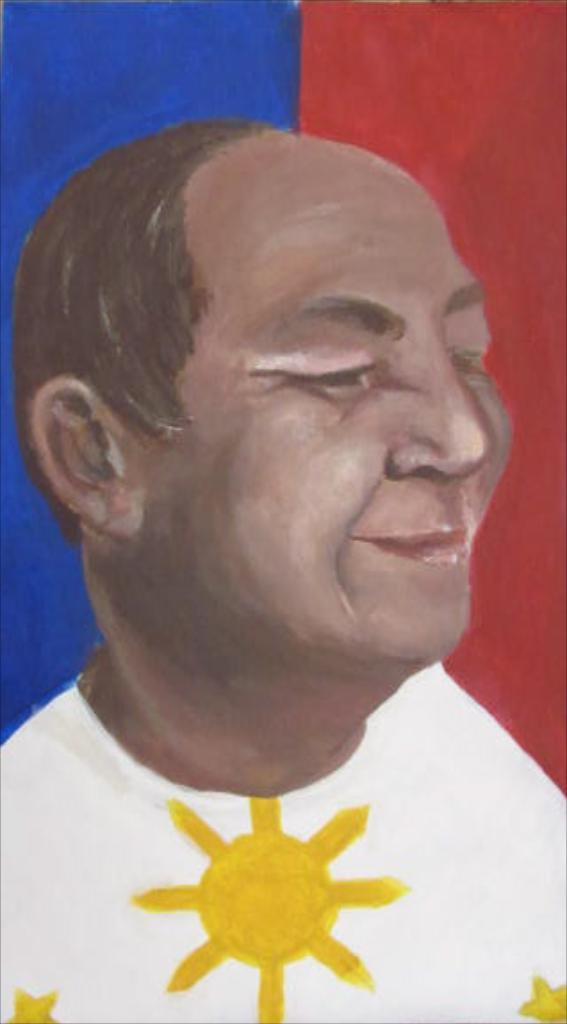What is the main subject of the image? There is a painting in the image. What does the painting depict? The painting depicts a person. What type of slope can be seen in the painting? There is no slope present in the painting; it depicts a person. How does the fog affect the visibility of the person in the painting? There is no fog present in the painting; it depicts a person without any weather conditions. 